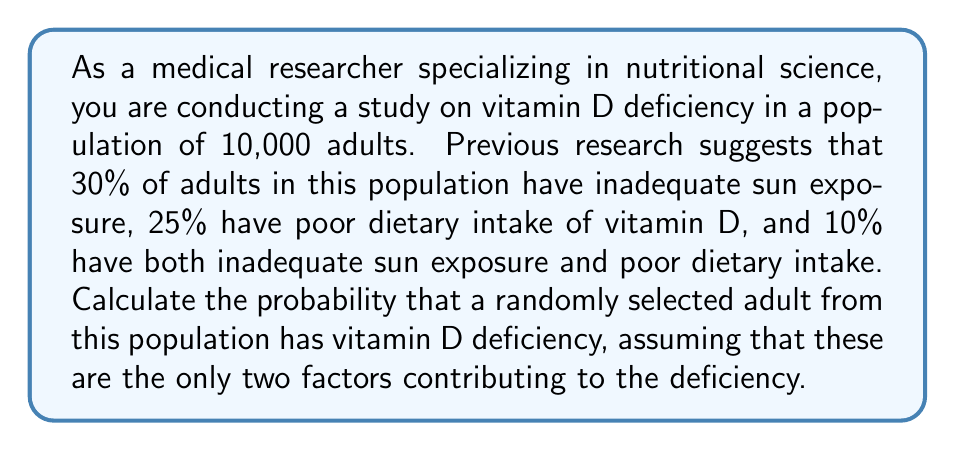Solve this math problem. To solve this problem, we'll use the concept of probability and set theory. Let's break it down step-by-step:

1. Define our events:
   A: Inadequate sun exposure
   B: Poor dietary intake of vitamin D

2. Given probabilities:
   P(A) = 30% = 0.30
   P(B) = 25% = 0.25
   P(A ∩ B) = 10% = 0.10

3. We need to find P(A ∪ B), which represents the probability of having vitamin D deficiency due to either inadequate sun exposure or poor dietary intake or both.

4. We can use the addition rule of probability:
   P(A ∪ B) = P(A) + P(B) - P(A ∩ B)

5. Substituting the values:
   P(A ∪ B) = 0.30 + 0.25 - 0.10

6. Calculate:
   P(A ∪ B) = 0.45

Therefore, the probability that a randomly selected adult from this population has vitamin D deficiency is 0.45 or 45%.

This can be represented mathematically as:

$$P(\text{Vitamin D Deficiency}) = P(A \cup B) = P(A) + P(B) - P(A \cap B) = 0.30 + 0.25 - 0.10 = 0.45$$
Answer: The probability that a randomly selected adult from this population has vitamin D deficiency is 0.45 or 45%. 